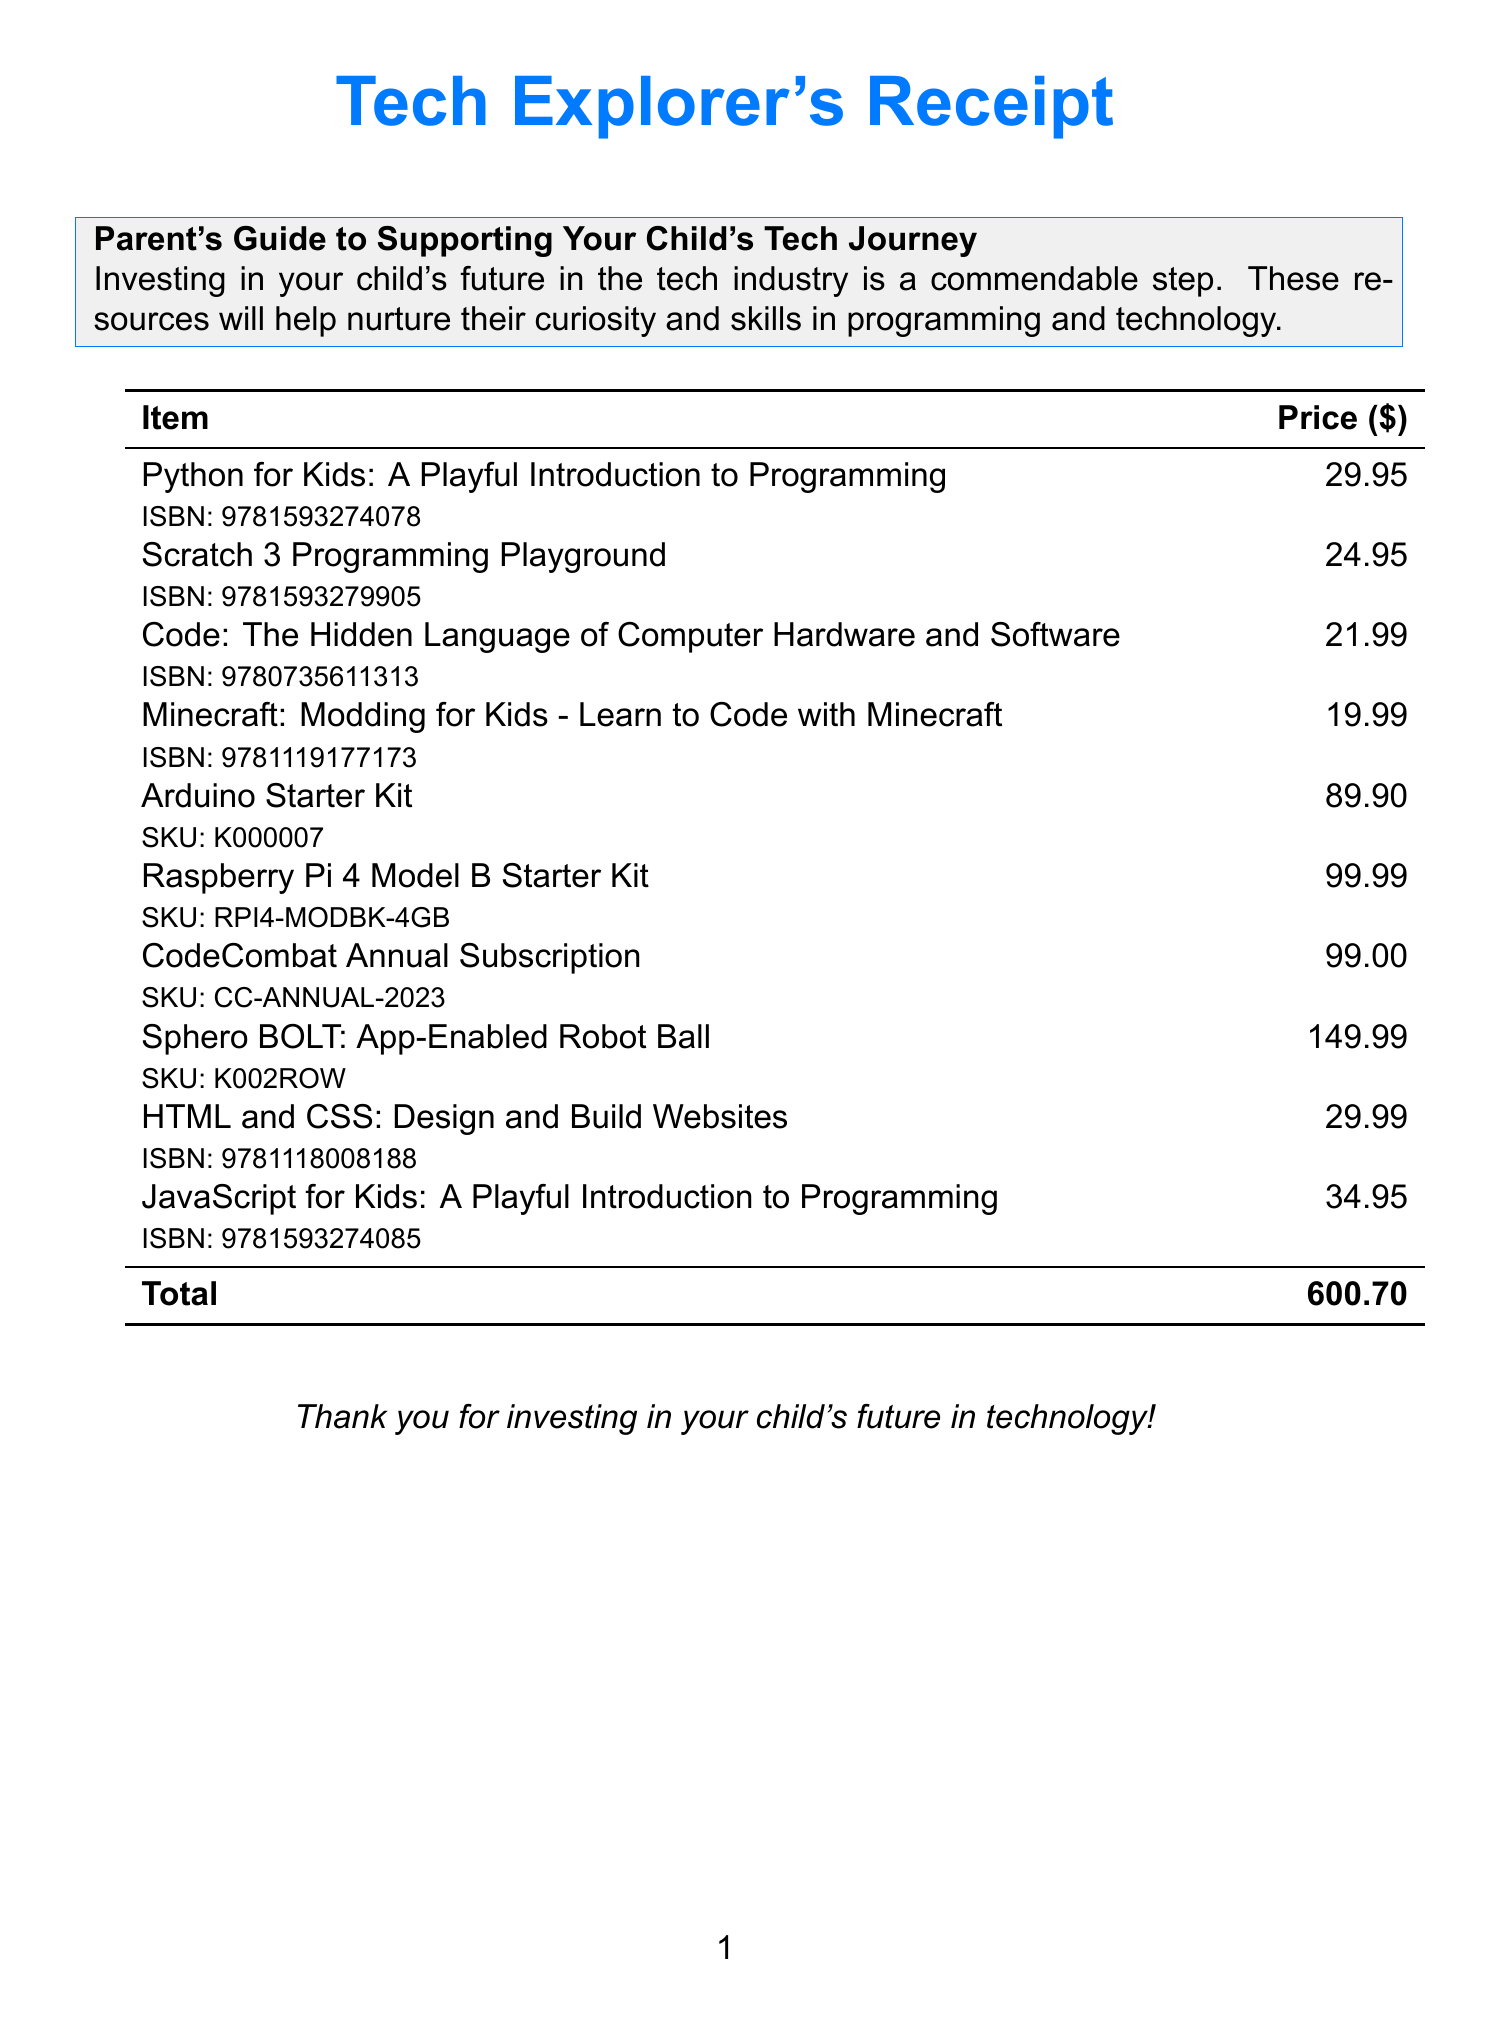What is the first item listed on the receipt? The first item listed in the document is "Python for Kids: A Playful Introduction to Programming."
Answer: Python for Kids: A Playful Introduction to Programming Who is the author of "JavaScript for Kids"? The document specifies that the author of "JavaScript for Kids: A Playful Introduction to Programming" is Nick Morgan.
Answer: Nick Morgan What is the price of the "Arduino Starter Kit"? The document indicates that the "Arduino Starter Kit" costs $89.90.
Answer: 89.90 What is the total amount on the receipt? The total referenced in the document is the sum of all individual prices, which is $600.70.
Answer: 600.70 What is the ISBN number of "Scratch 3 Programming Playground"? The document mentions the ISBN number of "Scratch 3 Programming Playground" as 9781593279905.
Answer: 9781593279905 How much does the "CodeCombat Annual Subscription" cost? The cost for the "CodeCombat Annual Subscription" is stated in the document as $99.00.
Answer: 99.00 Which item has the highest price on the receipt? The document shows that the "Sphero BOLT: App-Enabled Robot Ball" has the highest price at $149.99.
Answer: Sphero BOLT: App-Enabled Robot Ball What is the SKU of the "Raspberry Pi 4 Model B Starter Kit"? The document lists the SKU of the "Raspberry Pi 4 Model B Starter Kit" as RPI4-MODBK-4GB.
Answer: RPI4-MODBK-4GB What type of document is this? The format and content indicate that this is a receipt, specifically for educational programming materials.
Answer: Receipt 